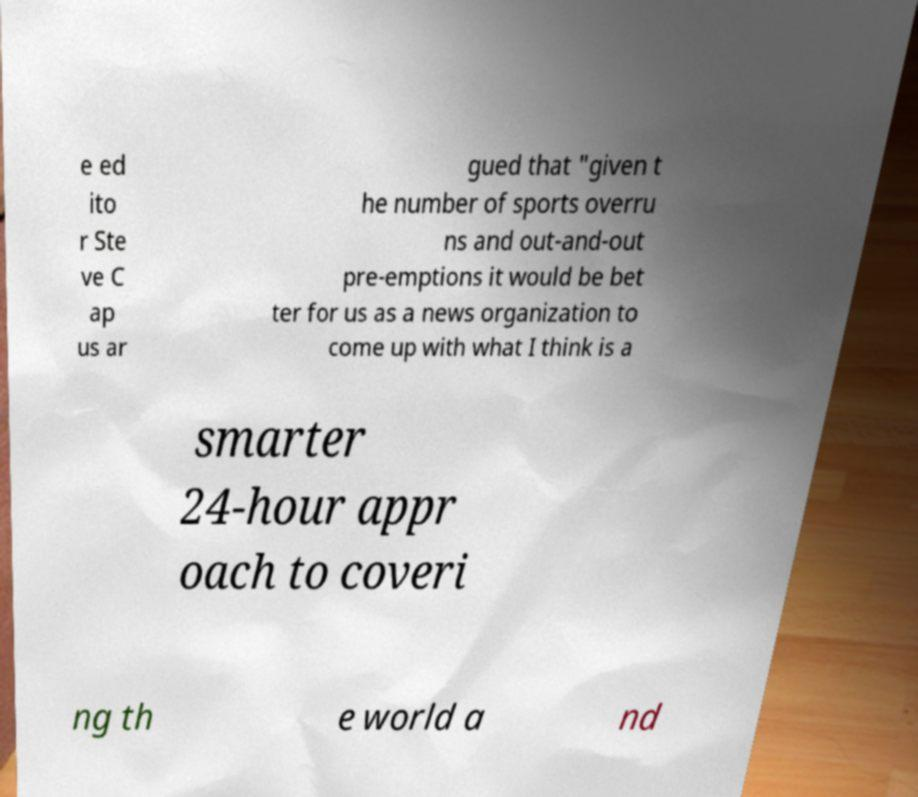Could you assist in decoding the text presented in this image and type it out clearly? e ed ito r Ste ve C ap us ar gued that "given t he number of sports overru ns and out-and-out pre-emptions it would be bet ter for us as a news organization to come up with what I think is a smarter 24-hour appr oach to coveri ng th e world a nd 